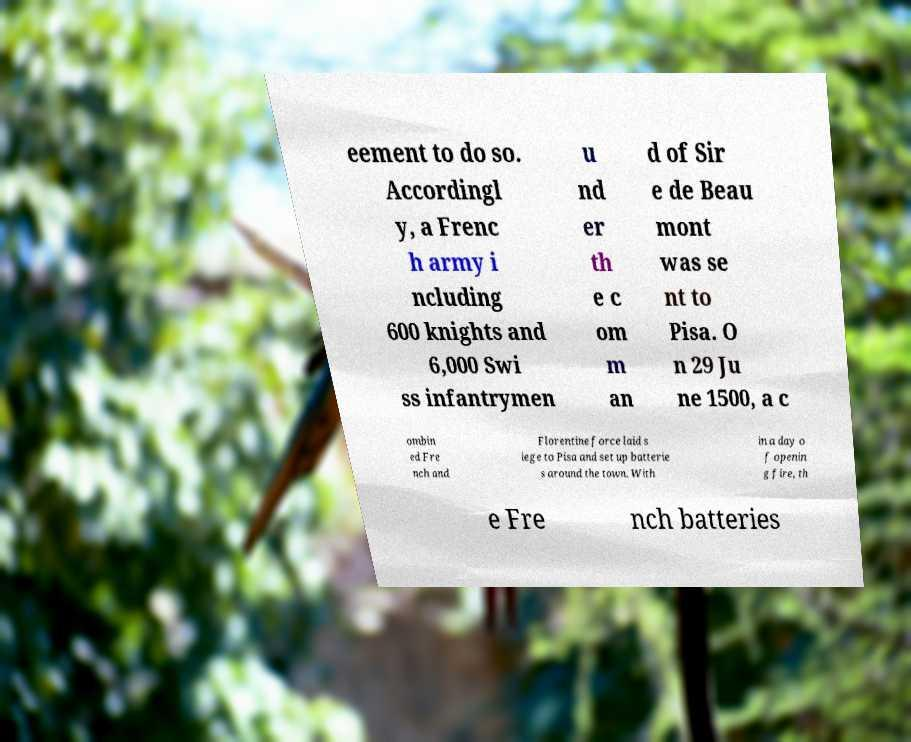What messages or text are displayed in this image? I need them in a readable, typed format. eement to do so. Accordingl y, a Frenc h army i ncluding 600 knights and 6,000 Swi ss infantrymen u nd er th e c om m an d of Sir e de Beau mont was se nt to Pisa. O n 29 Ju ne 1500, a c ombin ed Fre nch and Florentine force laid s iege to Pisa and set up batterie s around the town. With in a day o f openin g fire, th e Fre nch batteries 